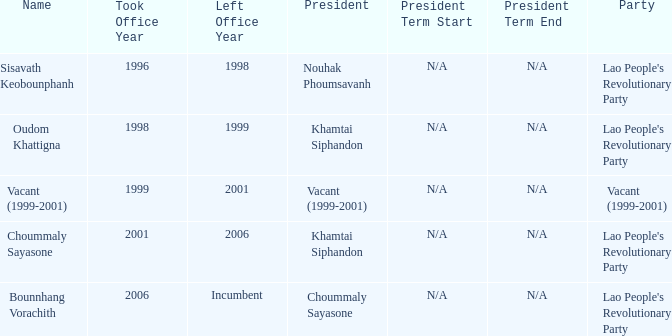What is Party, when Took Office is 1998? Lao People's Revolutionary Party. 